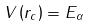Convert formula to latex. <formula><loc_0><loc_0><loc_500><loc_500>V \left ( r _ { c } \right ) = E _ { \alpha }</formula> 